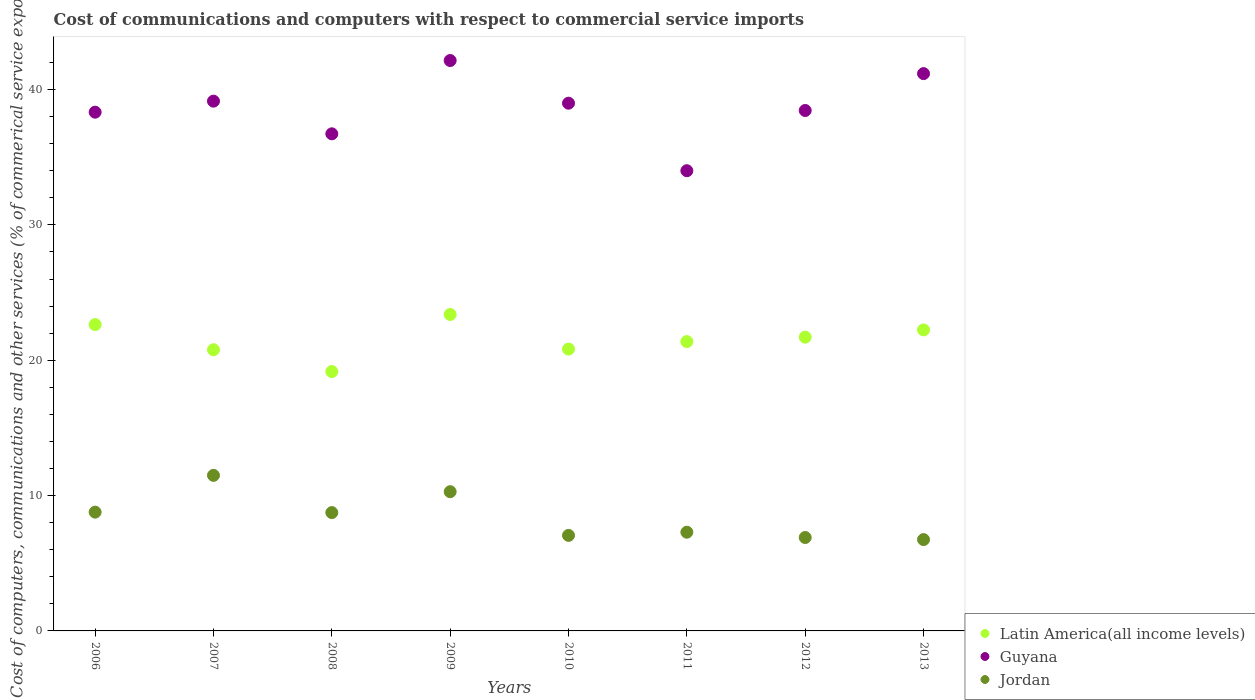What is the cost of communications and computers in Latin America(all income levels) in 2010?
Offer a very short reply. 20.82. Across all years, what is the maximum cost of communications and computers in Latin America(all income levels)?
Provide a succinct answer. 23.38. Across all years, what is the minimum cost of communications and computers in Jordan?
Your response must be concise. 6.75. In which year was the cost of communications and computers in Guyana maximum?
Your answer should be very brief. 2009. In which year was the cost of communications and computers in Latin America(all income levels) minimum?
Provide a succinct answer. 2008. What is the total cost of communications and computers in Guyana in the graph?
Keep it short and to the point. 308.95. What is the difference between the cost of communications and computers in Guyana in 2008 and that in 2013?
Provide a short and direct response. -4.45. What is the difference between the cost of communications and computers in Jordan in 2007 and the cost of communications and computers in Latin America(all income levels) in 2010?
Provide a succinct answer. -9.33. What is the average cost of communications and computers in Jordan per year?
Provide a succinct answer. 8.41. In the year 2012, what is the difference between the cost of communications and computers in Guyana and cost of communications and computers in Latin America(all income levels)?
Keep it short and to the point. 16.75. What is the ratio of the cost of communications and computers in Guyana in 2007 to that in 2008?
Your answer should be compact. 1.07. What is the difference between the highest and the second highest cost of communications and computers in Latin America(all income levels)?
Provide a succinct answer. 0.75. What is the difference between the highest and the lowest cost of communications and computers in Jordan?
Provide a short and direct response. 4.75. In how many years, is the cost of communications and computers in Latin America(all income levels) greater than the average cost of communications and computers in Latin America(all income levels) taken over all years?
Your answer should be very brief. 4. Is the sum of the cost of communications and computers in Latin America(all income levels) in 2006 and 2011 greater than the maximum cost of communications and computers in Guyana across all years?
Offer a very short reply. Yes. Is it the case that in every year, the sum of the cost of communications and computers in Jordan and cost of communications and computers in Latin America(all income levels)  is greater than the cost of communications and computers in Guyana?
Offer a very short reply. No. Is the cost of communications and computers in Jordan strictly greater than the cost of communications and computers in Guyana over the years?
Give a very brief answer. No. Is the cost of communications and computers in Latin America(all income levels) strictly less than the cost of communications and computers in Jordan over the years?
Your response must be concise. No. How many years are there in the graph?
Keep it short and to the point. 8. What is the difference between two consecutive major ticks on the Y-axis?
Make the answer very short. 10. Does the graph contain any zero values?
Offer a terse response. No. Does the graph contain grids?
Make the answer very short. No. What is the title of the graph?
Make the answer very short. Cost of communications and computers with respect to commercial service imports. What is the label or title of the X-axis?
Your answer should be compact. Years. What is the label or title of the Y-axis?
Provide a short and direct response. Cost of computers, communications and other services (% of commerical service exports). What is the Cost of computers, communications and other services (% of commerical service exports) in Latin America(all income levels) in 2006?
Your response must be concise. 22.63. What is the Cost of computers, communications and other services (% of commerical service exports) of Guyana in 2006?
Make the answer very short. 38.33. What is the Cost of computers, communications and other services (% of commerical service exports) of Jordan in 2006?
Ensure brevity in your answer.  8.78. What is the Cost of computers, communications and other services (% of commerical service exports) of Latin America(all income levels) in 2007?
Provide a short and direct response. 20.77. What is the Cost of computers, communications and other services (% of commerical service exports) in Guyana in 2007?
Provide a short and direct response. 39.14. What is the Cost of computers, communications and other services (% of commerical service exports) of Jordan in 2007?
Provide a succinct answer. 11.49. What is the Cost of computers, communications and other services (% of commerical service exports) in Latin America(all income levels) in 2008?
Keep it short and to the point. 19.16. What is the Cost of computers, communications and other services (% of commerical service exports) in Guyana in 2008?
Your answer should be very brief. 36.73. What is the Cost of computers, communications and other services (% of commerical service exports) in Jordan in 2008?
Give a very brief answer. 8.74. What is the Cost of computers, communications and other services (% of commerical service exports) of Latin America(all income levels) in 2009?
Ensure brevity in your answer.  23.38. What is the Cost of computers, communications and other services (% of commerical service exports) in Guyana in 2009?
Offer a very short reply. 42.14. What is the Cost of computers, communications and other services (% of commerical service exports) of Jordan in 2009?
Ensure brevity in your answer.  10.29. What is the Cost of computers, communications and other services (% of commerical service exports) in Latin America(all income levels) in 2010?
Offer a very short reply. 20.82. What is the Cost of computers, communications and other services (% of commerical service exports) in Guyana in 2010?
Your answer should be compact. 38.99. What is the Cost of computers, communications and other services (% of commerical service exports) of Jordan in 2010?
Provide a short and direct response. 7.06. What is the Cost of computers, communications and other services (% of commerical service exports) of Latin America(all income levels) in 2011?
Your response must be concise. 21.38. What is the Cost of computers, communications and other services (% of commerical service exports) in Guyana in 2011?
Your answer should be compact. 34. What is the Cost of computers, communications and other services (% of commerical service exports) of Jordan in 2011?
Your response must be concise. 7.29. What is the Cost of computers, communications and other services (% of commerical service exports) of Latin America(all income levels) in 2012?
Provide a short and direct response. 21.7. What is the Cost of computers, communications and other services (% of commerical service exports) in Guyana in 2012?
Provide a short and direct response. 38.45. What is the Cost of computers, communications and other services (% of commerical service exports) of Jordan in 2012?
Your response must be concise. 6.9. What is the Cost of computers, communications and other services (% of commerical service exports) in Latin America(all income levels) in 2013?
Make the answer very short. 22.24. What is the Cost of computers, communications and other services (% of commerical service exports) in Guyana in 2013?
Offer a terse response. 41.17. What is the Cost of computers, communications and other services (% of commerical service exports) of Jordan in 2013?
Provide a succinct answer. 6.75. Across all years, what is the maximum Cost of computers, communications and other services (% of commerical service exports) of Latin America(all income levels)?
Give a very brief answer. 23.38. Across all years, what is the maximum Cost of computers, communications and other services (% of commerical service exports) in Guyana?
Provide a succinct answer. 42.14. Across all years, what is the maximum Cost of computers, communications and other services (% of commerical service exports) in Jordan?
Keep it short and to the point. 11.49. Across all years, what is the minimum Cost of computers, communications and other services (% of commerical service exports) of Latin America(all income levels)?
Offer a very short reply. 19.16. Across all years, what is the minimum Cost of computers, communications and other services (% of commerical service exports) of Guyana?
Make the answer very short. 34. Across all years, what is the minimum Cost of computers, communications and other services (% of commerical service exports) in Jordan?
Offer a terse response. 6.75. What is the total Cost of computers, communications and other services (% of commerical service exports) in Latin America(all income levels) in the graph?
Offer a terse response. 172.09. What is the total Cost of computers, communications and other services (% of commerical service exports) in Guyana in the graph?
Your answer should be very brief. 308.95. What is the total Cost of computers, communications and other services (% of commerical service exports) in Jordan in the graph?
Your answer should be compact. 67.3. What is the difference between the Cost of computers, communications and other services (% of commerical service exports) in Latin America(all income levels) in 2006 and that in 2007?
Provide a succinct answer. 1.86. What is the difference between the Cost of computers, communications and other services (% of commerical service exports) in Guyana in 2006 and that in 2007?
Your response must be concise. -0.82. What is the difference between the Cost of computers, communications and other services (% of commerical service exports) of Jordan in 2006 and that in 2007?
Offer a very short reply. -2.72. What is the difference between the Cost of computers, communications and other services (% of commerical service exports) in Latin America(all income levels) in 2006 and that in 2008?
Give a very brief answer. 3.47. What is the difference between the Cost of computers, communications and other services (% of commerical service exports) in Guyana in 2006 and that in 2008?
Keep it short and to the point. 1.6. What is the difference between the Cost of computers, communications and other services (% of commerical service exports) of Jordan in 2006 and that in 2008?
Provide a short and direct response. 0.03. What is the difference between the Cost of computers, communications and other services (% of commerical service exports) in Latin America(all income levels) in 2006 and that in 2009?
Offer a terse response. -0.75. What is the difference between the Cost of computers, communications and other services (% of commerical service exports) in Guyana in 2006 and that in 2009?
Provide a succinct answer. -3.82. What is the difference between the Cost of computers, communications and other services (% of commerical service exports) in Jordan in 2006 and that in 2009?
Provide a succinct answer. -1.51. What is the difference between the Cost of computers, communications and other services (% of commerical service exports) in Latin America(all income levels) in 2006 and that in 2010?
Give a very brief answer. 1.81. What is the difference between the Cost of computers, communications and other services (% of commerical service exports) in Guyana in 2006 and that in 2010?
Provide a succinct answer. -0.66. What is the difference between the Cost of computers, communications and other services (% of commerical service exports) of Jordan in 2006 and that in 2010?
Provide a short and direct response. 1.72. What is the difference between the Cost of computers, communications and other services (% of commerical service exports) in Latin America(all income levels) in 2006 and that in 2011?
Ensure brevity in your answer.  1.26. What is the difference between the Cost of computers, communications and other services (% of commerical service exports) in Guyana in 2006 and that in 2011?
Your answer should be very brief. 4.33. What is the difference between the Cost of computers, communications and other services (% of commerical service exports) of Jordan in 2006 and that in 2011?
Provide a short and direct response. 1.48. What is the difference between the Cost of computers, communications and other services (% of commerical service exports) in Guyana in 2006 and that in 2012?
Make the answer very short. -0.13. What is the difference between the Cost of computers, communications and other services (% of commerical service exports) of Jordan in 2006 and that in 2012?
Your response must be concise. 1.88. What is the difference between the Cost of computers, communications and other services (% of commerical service exports) in Latin America(all income levels) in 2006 and that in 2013?
Your answer should be compact. 0.39. What is the difference between the Cost of computers, communications and other services (% of commerical service exports) of Guyana in 2006 and that in 2013?
Give a very brief answer. -2.85. What is the difference between the Cost of computers, communications and other services (% of commerical service exports) of Jordan in 2006 and that in 2013?
Offer a terse response. 2.03. What is the difference between the Cost of computers, communications and other services (% of commerical service exports) in Latin America(all income levels) in 2007 and that in 2008?
Make the answer very short. 1.61. What is the difference between the Cost of computers, communications and other services (% of commerical service exports) in Guyana in 2007 and that in 2008?
Offer a terse response. 2.41. What is the difference between the Cost of computers, communications and other services (% of commerical service exports) of Jordan in 2007 and that in 2008?
Your answer should be compact. 2.75. What is the difference between the Cost of computers, communications and other services (% of commerical service exports) in Latin America(all income levels) in 2007 and that in 2009?
Your answer should be very brief. -2.61. What is the difference between the Cost of computers, communications and other services (% of commerical service exports) in Guyana in 2007 and that in 2009?
Provide a short and direct response. -3. What is the difference between the Cost of computers, communications and other services (% of commerical service exports) of Jordan in 2007 and that in 2009?
Provide a succinct answer. 1.21. What is the difference between the Cost of computers, communications and other services (% of commerical service exports) of Guyana in 2007 and that in 2010?
Provide a succinct answer. 0.15. What is the difference between the Cost of computers, communications and other services (% of commerical service exports) in Jordan in 2007 and that in 2010?
Give a very brief answer. 4.44. What is the difference between the Cost of computers, communications and other services (% of commerical service exports) of Latin America(all income levels) in 2007 and that in 2011?
Make the answer very short. -0.6. What is the difference between the Cost of computers, communications and other services (% of commerical service exports) in Guyana in 2007 and that in 2011?
Your response must be concise. 5.14. What is the difference between the Cost of computers, communications and other services (% of commerical service exports) in Jordan in 2007 and that in 2011?
Make the answer very short. 4.2. What is the difference between the Cost of computers, communications and other services (% of commerical service exports) of Latin America(all income levels) in 2007 and that in 2012?
Your answer should be very brief. -0.93. What is the difference between the Cost of computers, communications and other services (% of commerical service exports) in Guyana in 2007 and that in 2012?
Provide a succinct answer. 0.69. What is the difference between the Cost of computers, communications and other services (% of commerical service exports) in Jordan in 2007 and that in 2012?
Your answer should be compact. 4.59. What is the difference between the Cost of computers, communications and other services (% of commerical service exports) in Latin America(all income levels) in 2007 and that in 2013?
Your response must be concise. -1.47. What is the difference between the Cost of computers, communications and other services (% of commerical service exports) of Guyana in 2007 and that in 2013?
Ensure brevity in your answer.  -2.03. What is the difference between the Cost of computers, communications and other services (% of commerical service exports) of Jordan in 2007 and that in 2013?
Ensure brevity in your answer.  4.75. What is the difference between the Cost of computers, communications and other services (% of commerical service exports) in Latin America(all income levels) in 2008 and that in 2009?
Your answer should be very brief. -4.22. What is the difference between the Cost of computers, communications and other services (% of commerical service exports) in Guyana in 2008 and that in 2009?
Offer a very short reply. -5.42. What is the difference between the Cost of computers, communications and other services (% of commerical service exports) of Jordan in 2008 and that in 2009?
Keep it short and to the point. -1.54. What is the difference between the Cost of computers, communications and other services (% of commerical service exports) in Latin America(all income levels) in 2008 and that in 2010?
Your answer should be very brief. -1.66. What is the difference between the Cost of computers, communications and other services (% of commerical service exports) of Guyana in 2008 and that in 2010?
Make the answer very short. -2.26. What is the difference between the Cost of computers, communications and other services (% of commerical service exports) in Jordan in 2008 and that in 2010?
Offer a terse response. 1.68. What is the difference between the Cost of computers, communications and other services (% of commerical service exports) of Latin America(all income levels) in 2008 and that in 2011?
Offer a terse response. -2.21. What is the difference between the Cost of computers, communications and other services (% of commerical service exports) in Guyana in 2008 and that in 2011?
Your response must be concise. 2.73. What is the difference between the Cost of computers, communications and other services (% of commerical service exports) in Jordan in 2008 and that in 2011?
Your answer should be compact. 1.45. What is the difference between the Cost of computers, communications and other services (% of commerical service exports) of Latin America(all income levels) in 2008 and that in 2012?
Your answer should be very brief. -2.54. What is the difference between the Cost of computers, communications and other services (% of commerical service exports) of Guyana in 2008 and that in 2012?
Ensure brevity in your answer.  -1.72. What is the difference between the Cost of computers, communications and other services (% of commerical service exports) in Jordan in 2008 and that in 2012?
Keep it short and to the point. 1.84. What is the difference between the Cost of computers, communications and other services (% of commerical service exports) in Latin America(all income levels) in 2008 and that in 2013?
Offer a very short reply. -3.08. What is the difference between the Cost of computers, communications and other services (% of commerical service exports) of Guyana in 2008 and that in 2013?
Your response must be concise. -4.45. What is the difference between the Cost of computers, communications and other services (% of commerical service exports) in Jordan in 2008 and that in 2013?
Offer a terse response. 1.99. What is the difference between the Cost of computers, communications and other services (% of commerical service exports) of Latin America(all income levels) in 2009 and that in 2010?
Your answer should be very brief. 2.56. What is the difference between the Cost of computers, communications and other services (% of commerical service exports) of Guyana in 2009 and that in 2010?
Offer a very short reply. 3.15. What is the difference between the Cost of computers, communications and other services (% of commerical service exports) in Jordan in 2009 and that in 2010?
Your answer should be compact. 3.23. What is the difference between the Cost of computers, communications and other services (% of commerical service exports) of Latin America(all income levels) in 2009 and that in 2011?
Your response must be concise. 2. What is the difference between the Cost of computers, communications and other services (% of commerical service exports) in Guyana in 2009 and that in 2011?
Your answer should be very brief. 8.14. What is the difference between the Cost of computers, communications and other services (% of commerical service exports) of Jordan in 2009 and that in 2011?
Provide a succinct answer. 2.99. What is the difference between the Cost of computers, communications and other services (% of commerical service exports) in Latin America(all income levels) in 2009 and that in 2012?
Give a very brief answer. 1.68. What is the difference between the Cost of computers, communications and other services (% of commerical service exports) in Guyana in 2009 and that in 2012?
Your answer should be compact. 3.69. What is the difference between the Cost of computers, communications and other services (% of commerical service exports) of Jordan in 2009 and that in 2012?
Your answer should be very brief. 3.38. What is the difference between the Cost of computers, communications and other services (% of commerical service exports) of Latin America(all income levels) in 2009 and that in 2013?
Your response must be concise. 1.14. What is the difference between the Cost of computers, communications and other services (% of commerical service exports) of Guyana in 2009 and that in 2013?
Ensure brevity in your answer.  0.97. What is the difference between the Cost of computers, communications and other services (% of commerical service exports) of Jordan in 2009 and that in 2013?
Provide a succinct answer. 3.54. What is the difference between the Cost of computers, communications and other services (% of commerical service exports) of Latin America(all income levels) in 2010 and that in 2011?
Offer a very short reply. -0.55. What is the difference between the Cost of computers, communications and other services (% of commerical service exports) of Guyana in 2010 and that in 2011?
Your answer should be very brief. 4.99. What is the difference between the Cost of computers, communications and other services (% of commerical service exports) of Jordan in 2010 and that in 2011?
Provide a succinct answer. -0.23. What is the difference between the Cost of computers, communications and other services (% of commerical service exports) in Latin America(all income levels) in 2010 and that in 2012?
Make the answer very short. -0.88. What is the difference between the Cost of computers, communications and other services (% of commerical service exports) in Guyana in 2010 and that in 2012?
Offer a terse response. 0.54. What is the difference between the Cost of computers, communications and other services (% of commerical service exports) in Jordan in 2010 and that in 2012?
Your response must be concise. 0.16. What is the difference between the Cost of computers, communications and other services (% of commerical service exports) of Latin America(all income levels) in 2010 and that in 2013?
Your answer should be very brief. -1.42. What is the difference between the Cost of computers, communications and other services (% of commerical service exports) in Guyana in 2010 and that in 2013?
Ensure brevity in your answer.  -2.19. What is the difference between the Cost of computers, communications and other services (% of commerical service exports) of Jordan in 2010 and that in 2013?
Give a very brief answer. 0.31. What is the difference between the Cost of computers, communications and other services (% of commerical service exports) in Latin America(all income levels) in 2011 and that in 2012?
Provide a short and direct response. -0.33. What is the difference between the Cost of computers, communications and other services (% of commerical service exports) of Guyana in 2011 and that in 2012?
Offer a very short reply. -4.45. What is the difference between the Cost of computers, communications and other services (% of commerical service exports) in Jordan in 2011 and that in 2012?
Your answer should be compact. 0.39. What is the difference between the Cost of computers, communications and other services (% of commerical service exports) of Latin America(all income levels) in 2011 and that in 2013?
Ensure brevity in your answer.  -0.86. What is the difference between the Cost of computers, communications and other services (% of commerical service exports) in Guyana in 2011 and that in 2013?
Provide a short and direct response. -7.17. What is the difference between the Cost of computers, communications and other services (% of commerical service exports) in Jordan in 2011 and that in 2013?
Your answer should be very brief. 0.55. What is the difference between the Cost of computers, communications and other services (% of commerical service exports) of Latin America(all income levels) in 2012 and that in 2013?
Provide a short and direct response. -0.54. What is the difference between the Cost of computers, communications and other services (% of commerical service exports) of Guyana in 2012 and that in 2013?
Provide a short and direct response. -2.72. What is the difference between the Cost of computers, communications and other services (% of commerical service exports) of Jordan in 2012 and that in 2013?
Make the answer very short. 0.15. What is the difference between the Cost of computers, communications and other services (% of commerical service exports) in Latin America(all income levels) in 2006 and the Cost of computers, communications and other services (% of commerical service exports) in Guyana in 2007?
Give a very brief answer. -16.51. What is the difference between the Cost of computers, communications and other services (% of commerical service exports) of Latin America(all income levels) in 2006 and the Cost of computers, communications and other services (% of commerical service exports) of Jordan in 2007?
Offer a terse response. 11.14. What is the difference between the Cost of computers, communications and other services (% of commerical service exports) of Guyana in 2006 and the Cost of computers, communications and other services (% of commerical service exports) of Jordan in 2007?
Ensure brevity in your answer.  26.83. What is the difference between the Cost of computers, communications and other services (% of commerical service exports) in Latin America(all income levels) in 2006 and the Cost of computers, communications and other services (% of commerical service exports) in Guyana in 2008?
Provide a short and direct response. -14.09. What is the difference between the Cost of computers, communications and other services (% of commerical service exports) of Latin America(all income levels) in 2006 and the Cost of computers, communications and other services (% of commerical service exports) of Jordan in 2008?
Offer a very short reply. 13.89. What is the difference between the Cost of computers, communications and other services (% of commerical service exports) in Guyana in 2006 and the Cost of computers, communications and other services (% of commerical service exports) in Jordan in 2008?
Your answer should be very brief. 29.58. What is the difference between the Cost of computers, communications and other services (% of commerical service exports) of Latin America(all income levels) in 2006 and the Cost of computers, communications and other services (% of commerical service exports) of Guyana in 2009?
Keep it short and to the point. -19.51. What is the difference between the Cost of computers, communications and other services (% of commerical service exports) in Latin America(all income levels) in 2006 and the Cost of computers, communications and other services (% of commerical service exports) in Jordan in 2009?
Provide a short and direct response. 12.35. What is the difference between the Cost of computers, communications and other services (% of commerical service exports) of Guyana in 2006 and the Cost of computers, communications and other services (% of commerical service exports) of Jordan in 2009?
Offer a very short reply. 28.04. What is the difference between the Cost of computers, communications and other services (% of commerical service exports) in Latin America(all income levels) in 2006 and the Cost of computers, communications and other services (% of commerical service exports) in Guyana in 2010?
Provide a short and direct response. -16.36. What is the difference between the Cost of computers, communications and other services (% of commerical service exports) of Latin America(all income levels) in 2006 and the Cost of computers, communications and other services (% of commerical service exports) of Jordan in 2010?
Provide a short and direct response. 15.57. What is the difference between the Cost of computers, communications and other services (% of commerical service exports) of Guyana in 2006 and the Cost of computers, communications and other services (% of commerical service exports) of Jordan in 2010?
Offer a terse response. 31.27. What is the difference between the Cost of computers, communications and other services (% of commerical service exports) in Latin America(all income levels) in 2006 and the Cost of computers, communications and other services (% of commerical service exports) in Guyana in 2011?
Provide a short and direct response. -11.37. What is the difference between the Cost of computers, communications and other services (% of commerical service exports) of Latin America(all income levels) in 2006 and the Cost of computers, communications and other services (% of commerical service exports) of Jordan in 2011?
Your response must be concise. 15.34. What is the difference between the Cost of computers, communications and other services (% of commerical service exports) of Guyana in 2006 and the Cost of computers, communications and other services (% of commerical service exports) of Jordan in 2011?
Give a very brief answer. 31.03. What is the difference between the Cost of computers, communications and other services (% of commerical service exports) in Latin America(all income levels) in 2006 and the Cost of computers, communications and other services (% of commerical service exports) in Guyana in 2012?
Offer a terse response. -15.82. What is the difference between the Cost of computers, communications and other services (% of commerical service exports) of Latin America(all income levels) in 2006 and the Cost of computers, communications and other services (% of commerical service exports) of Jordan in 2012?
Offer a very short reply. 15.73. What is the difference between the Cost of computers, communications and other services (% of commerical service exports) of Guyana in 2006 and the Cost of computers, communications and other services (% of commerical service exports) of Jordan in 2012?
Provide a succinct answer. 31.42. What is the difference between the Cost of computers, communications and other services (% of commerical service exports) of Latin America(all income levels) in 2006 and the Cost of computers, communications and other services (% of commerical service exports) of Guyana in 2013?
Ensure brevity in your answer.  -18.54. What is the difference between the Cost of computers, communications and other services (% of commerical service exports) of Latin America(all income levels) in 2006 and the Cost of computers, communications and other services (% of commerical service exports) of Jordan in 2013?
Make the answer very short. 15.88. What is the difference between the Cost of computers, communications and other services (% of commerical service exports) in Guyana in 2006 and the Cost of computers, communications and other services (% of commerical service exports) in Jordan in 2013?
Provide a short and direct response. 31.58. What is the difference between the Cost of computers, communications and other services (% of commerical service exports) in Latin America(all income levels) in 2007 and the Cost of computers, communications and other services (% of commerical service exports) in Guyana in 2008?
Offer a terse response. -15.95. What is the difference between the Cost of computers, communications and other services (% of commerical service exports) of Latin America(all income levels) in 2007 and the Cost of computers, communications and other services (% of commerical service exports) of Jordan in 2008?
Keep it short and to the point. 12.03. What is the difference between the Cost of computers, communications and other services (% of commerical service exports) of Guyana in 2007 and the Cost of computers, communications and other services (% of commerical service exports) of Jordan in 2008?
Your response must be concise. 30.4. What is the difference between the Cost of computers, communications and other services (% of commerical service exports) of Latin America(all income levels) in 2007 and the Cost of computers, communications and other services (% of commerical service exports) of Guyana in 2009?
Your response must be concise. -21.37. What is the difference between the Cost of computers, communications and other services (% of commerical service exports) in Latin America(all income levels) in 2007 and the Cost of computers, communications and other services (% of commerical service exports) in Jordan in 2009?
Your answer should be very brief. 10.49. What is the difference between the Cost of computers, communications and other services (% of commerical service exports) of Guyana in 2007 and the Cost of computers, communications and other services (% of commerical service exports) of Jordan in 2009?
Your response must be concise. 28.85. What is the difference between the Cost of computers, communications and other services (% of commerical service exports) of Latin America(all income levels) in 2007 and the Cost of computers, communications and other services (% of commerical service exports) of Guyana in 2010?
Offer a terse response. -18.22. What is the difference between the Cost of computers, communications and other services (% of commerical service exports) of Latin America(all income levels) in 2007 and the Cost of computers, communications and other services (% of commerical service exports) of Jordan in 2010?
Offer a terse response. 13.72. What is the difference between the Cost of computers, communications and other services (% of commerical service exports) in Guyana in 2007 and the Cost of computers, communications and other services (% of commerical service exports) in Jordan in 2010?
Provide a succinct answer. 32.08. What is the difference between the Cost of computers, communications and other services (% of commerical service exports) in Latin America(all income levels) in 2007 and the Cost of computers, communications and other services (% of commerical service exports) in Guyana in 2011?
Keep it short and to the point. -13.23. What is the difference between the Cost of computers, communications and other services (% of commerical service exports) in Latin America(all income levels) in 2007 and the Cost of computers, communications and other services (% of commerical service exports) in Jordan in 2011?
Your response must be concise. 13.48. What is the difference between the Cost of computers, communications and other services (% of commerical service exports) of Guyana in 2007 and the Cost of computers, communications and other services (% of commerical service exports) of Jordan in 2011?
Your response must be concise. 31.85. What is the difference between the Cost of computers, communications and other services (% of commerical service exports) in Latin America(all income levels) in 2007 and the Cost of computers, communications and other services (% of commerical service exports) in Guyana in 2012?
Provide a short and direct response. -17.68. What is the difference between the Cost of computers, communications and other services (% of commerical service exports) of Latin America(all income levels) in 2007 and the Cost of computers, communications and other services (% of commerical service exports) of Jordan in 2012?
Offer a very short reply. 13.87. What is the difference between the Cost of computers, communications and other services (% of commerical service exports) of Guyana in 2007 and the Cost of computers, communications and other services (% of commerical service exports) of Jordan in 2012?
Ensure brevity in your answer.  32.24. What is the difference between the Cost of computers, communications and other services (% of commerical service exports) of Latin America(all income levels) in 2007 and the Cost of computers, communications and other services (% of commerical service exports) of Guyana in 2013?
Give a very brief answer. -20.4. What is the difference between the Cost of computers, communications and other services (% of commerical service exports) in Latin America(all income levels) in 2007 and the Cost of computers, communications and other services (% of commerical service exports) in Jordan in 2013?
Provide a succinct answer. 14.03. What is the difference between the Cost of computers, communications and other services (% of commerical service exports) of Guyana in 2007 and the Cost of computers, communications and other services (% of commerical service exports) of Jordan in 2013?
Keep it short and to the point. 32.39. What is the difference between the Cost of computers, communications and other services (% of commerical service exports) in Latin America(all income levels) in 2008 and the Cost of computers, communications and other services (% of commerical service exports) in Guyana in 2009?
Ensure brevity in your answer.  -22.98. What is the difference between the Cost of computers, communications and other services (% of commerical service exports) of Latin America(all income levels) in 2008 and the Cost of computers, communications and other services (% of commerical service exports) of Jordan in 2009?
Offer a very short reply. 8.88. What is the difference between the Cost of computers, communications and other services (% of commerical service exports) in Guyana in 2008 and the Cost of computers, communications and other services (% of commerical service exports) in Jordan in 2009?
Offer a terse response. 26.44. What is the difference between the Cost of computers, communications and other services (% of commerical service exports) in Latin America(all income levels) in 2008 and the Cost of computers, communications and other services (% of commerical service exports) in Guyana in 2010?
Keep it short and to the point. -19.83. What is the difference between the Cost of computers, communications and other services (% of commerical service exports) of Latin America(all income levels) in 2008 and the Cost of computers, communications and other services (% of commerical service exports) of Jordan in 2010?
Offer a very short reply. 12.1. What is the difference between the Cost of computers, communications and other services (% of commerical service exports) in Guyana in 2008 and the Cost of computers, communications and other services (% of commerical service exports) in Jordan in 2010?
Your answer should be very brief. 29.67. What is the difference between the Cost of computers, communications and other services (% of commerical service exports) of Latin America(all income levels) in 2008 and the Cost of computers, communications and other services (% of commerical service exports) of Guyana in 2011?
Your response must be concise. -14.84. What is the difference between the Cost of computers, communications and other services (% of commerical service exports) of Latin America(all income levels) in 2008 and the Cost of computers, communications and other services (% of commerical service exports) of Jordan in 2011?
Ensure brevity in your answer.  11.87. What is the difference between the Cost of computers, communications and other services (% of commerical service exports) of Guyana in 2008 and the Cost of computers, communications and other services (% of commerical service exports) of Jordan in 2011?
Provide a short and direct response. 29.43. What is the difference between the Cost of computers, communications and other services (% of commerical service exports) in Latin America(all income levels) in 2008 and the Cost of computers, communications and other services (% of commerical service exports) in Guyana in 2012?
Your answer should be very brief. -19.29. What is the difference between the Cost of computers, communications and other services (% of commerical service exports) in Latin America(all income levels) in 2008 and the Cost of computers, communications and other services (% of commerical service exports) in Jordan in 2012?
Give a very brief answer. 12.26. What is the difference between the Cost of computers, communications and other services (% of commerical service exports) in Guyana in 2008 and the Cost of computers, communications and other services (% of commerical service exports) in Jordan in 2012?
Your answer should be compact. 29.82. What is the difference between the Cost of computers, communications and other services (% of commerical service exports) in Latin America(all income levels) in 2008 and the Cost of computers, communications and other services (% of commerical service exports) in Guyana in 2013?
Your answer should be compact. -22.01. What is the difference between the Cost of computers, communications and other services (% of commerical service exports) in Latin America(all income levels) in 2008 and the Cost of computers, communications and other services (% of commerical service exports) in Jordan in 2013?
Your answer should be very brief. 12.41. What is the difference between the Cost of computers, communications and other services (% of commerical service exports) in Guyana in 2008 and the Cost of computers, communications and other services (% of commerical service exports) in Jordan in 2013?
Your answer should be very brief. 29.98. What is the difference between the Cost of computers, communications and other services (% of commerical service exports) of Latin America(all income levels) in 2009 and the Cost of computers, communications and other services (% of commerical service exports) of Guyana in 2010?
Give a very brief answer. -15.61. What is the difference between the Cost of computers, communications and other services (% of commerical service exports) in Latin America(all income levels) in 2009 and the Cost of computers, communications and other services (% of commerical service exports) in Jordan in 2010?
Ensure brevity in your answer.  16.32. What is the difference between the Cost of computers, communications and other services (% of commerical service exports) of Guyana in 2009 and the Cost of computers, communications and other services (% of commerical service exports) of Jordan in 2010?
Provide a short and direct response. 35.08. What is the difference between the Cost of computers, communications and other services (% of commerical service exports) of Latin America(all income levels) in 2009 and the Cost of computers, communications and other services (% of commerical service exports) of Guyana in 2011?
Make the answer very short. -10.62. What is the difference between the Cost of computers, communications and other services (% of commerical service exports) in Latin America(all income levels) in 2009 and the Cost of computers, communications and other services (% of commerical service exports) in Jordan in 2011?
Offer a very short reply. 16.09. What is the difference between the Cost of computers, communications and other services (% of commerical service exports) of Guyana in 2009 and the Cost of computers, communications and other services (% of commerical service exports) of Jordan in 2011?
Your answer should be very brief. 34.85. What is the difference between the Cost of computers, communications and other services (% of commerical service exports) of Latin America(all income levels) in 2009 and the Cost of computers, communications and other services (% of commerical service exports) of Guyana in 2012?
Provide a short and direct response. -15.07. What is the difference between the Cost of computers, communications and other services (% of commerical service exports) in Latin America(all income levels) in 2009 and the Cost of computers, communications and other services (% of commerical service exports) in Jordan in 2012?
Give a very brief answer. 16.48. What is the difference between the Cost of computers, communications and other services (% of commerical service exports) in Guyana in 2009 and the Cost of computers, communications and other services (% of commerical service exports) in Jordan in 2012?
Provide a succinct answer. 35.24. What is the difference between the Cost of computers, communications and other services (% of commerical service exports) of Latin America(all income levels) in 2009 and the Cost of computers, communications and other services (% of commerical service exports) of Guyana in 2013?
Offer a terse response. -17.79. What is the difference between the Cost of computers, communications and other services (% of commerical service exports) in Latin America(all income levels) in 2009 and the Cost of computers, communications and other services (% of commerical service exports) in Jordan in 2013?
Provide a short and direct response. 16.63. What is the difference between the Cost of computers, communications and other services (% of commerical service exports) in Guyana in 2009 and the Cost of computers, communications and other services (% of commerical service exports) in Jordan in 2013?
Your response must be concise. 35.39. What is the difference between the Cost of computers, communications and other services (% of commerical service exports) in Latin America(all income levels) in 2010 and the Cost of computers, communications and other services (% of commerical service exports) in Guyana in 2011?
Provide a succinct answer. -13.18. What is the difference between the Cost of computers, communications and other services (% of commerical service exports) in Latin America(all income levels) in 2010 and the Cost of computers, communications and other services (% of commerical service exports) in Jordan in 2011?
Keep it short and to the point. 13.53. What is the difference between the Cost of computers, communications and other services (% of commerical service exports) of Guyana in 2010 and the Cost of computers, communications and other services (% of commerical service exports) of Jordan in 2011?
Ensure brevity in your answer.  31.7. What is the difference between the Cost of computers, communications and other services (% of commerical service exports) in Latin America(all income levels) in 2010 and the Cost of computers, communications and other services (% of commerical service exports) in Guyana in 2012?
Give a very brief answer. -17.63. What is the difference between the Cost of computers, communications and other services (% of commerical service exports) in Latin America(all income levels) in 2010 and the Cost of computers, communications and other services (% of commerical service exports) in Jordan in 2012?
Ensure brevity in your answer.  13.92. What is the difference between the Cost of computers, communications and other services (% of commerical service exports) in Guyana in 2010 and the Cost of computers, communications and other services (% of commerical service exports) in Jordan in 2012?
Keep it short and to the point. 32.09. What is the difference between the Cost of computers, communications and other services (% of commerical service exports) of Latin America(all income levels) in 2010 and the Cost of computers, communications and other services (% of commerical service exports) of Guyana in 2013?
Offer a very short reply. -20.35. What is the difference between the Cost of computers, communications and other services (% of commerical service exports) in Latin America(all income levels) in 2010 and the Cost of computers, communications and other services (% of commerical service exports) in Jordan in 2013?
Your response must be concise. 14.08. What is the difference between the Cost of computers, communications and other services (% of commerical service exports) in Guyana in 2010 and the Cost of computers, communications and other services (% of commerical service exports) in Jordan in 2013?
Offer a very short reply. 32.24. What is the difference between the Cost of computers, communications and other services (% of commerical service exports) of Latin America(all income levels) in 2011 and the Cost of computers, communications and other services (% of commerical service exports) of Guyana in 2012?
Provide a succinct answer. -17.07. What is the difference between the Cost of computers, communications and other services (% of commerical service exports) of Latin America(all income levels) in 2011 and the Cost of computers, communications and other services (% of commerical service exports) of Jordan in 2012?
Your answer should be compact. 14.47. What is the difference between the Cost of computers, communications and other services (% of commerical service exports) in Guyana in 2011 and the Cost of computers, communications and other services (% of commerical service exports) in Jordan in 2012?
Offer a terse response. 27.1. What is the difference between the Cost of computers, communications and other services (% of commerical service exports) in Latin America(all income levels) in 2011 and the Cost of computers, communications and other services (% of commerical service exports) in Guyana in 2013?
Offer a terse response. -19.8. What is the difference between the Cost of computers, communications and other services (% of commerical service exports) in Latin America(all income levels) in 2011 and the Cost of computers, communications and other services (% of commerical service exports) in Jordan in 2013?
Give a very brief answer. 14.63. What is the difference between the Cost of computers, communications and other services (% of commerical service exports) of Guyana in 2011 and the Cost of computers, communications and other services (% of commerical service exports) of Jordan in 2013?
Make the answer very short. 27.25. What is the difference between the Cost of computers, communications and other services (% of commerical service exports) in Latin America(all income levels) in 2012 and the Cost of computers, communications and other services (% of commerical service exports) in Guyana in 2013?
Ensure brevity in your answer.  -19.47. What is the difference between the Cost of computers, communications and other services (% of commerical service exports) in Latin America(all income levels) in 2012 and the Cost of computers, communications and other services (% of commerical service exports) in Jordan in 2013?
Your answer should be very brief. 14.96. What is the difference between the Cost of computers, communications and other services (% of commerical service exports) of Guyana in 2012 and the Cost of computers, communications and other services (% of commerical service exports) of Jordan in 2013?
Ensure brevity in your answer.  31.7. What is the average Cost of computers, communications and other services (% of commerical service exports) of Latin America(all income levels) per year?
Ensure brevity in your answer.  21.51. What is the average Cost of computers, communications and other services (% of commerical service exports) of Guyana per year?
Your answer should be very brief. 38.62. What is the average Cost of computers, communications and other services (% of commerical service exports) of Jordan per year?
Provide a succinct answer. 8.41. In the year 2006, what is the difference between the Cost of computers, communications and other services (% of commerical service exports) in Latin America(all income levels) and Cost of computers, communications and other services (% of commerical service exports) in Guyana?
Provide a short and direct response. -15.69. In the year 2006, what is the difference between the Cost of computers, communications and other services (% of commerical service exports) in Latin America(all income levels) and Cost of computers, communications and other services (% of commerical service exports) in Jordan?
Give a very brief answer. 13.86. In the year 2006, what is the difference between the Cost of computers, communications and other services (% of commerical service exports) of Guyana and Cost of computers, communications and other services (% of commerical service exports) of Jordan?
Give a very brief answer. 29.55. In the year 2007, what is the difference between the Cost of computers, communications and other services (% of commerical service exports) in Latin America(all income levels) and Cost of computers, communications and other services (% of commerical service exports) in Guyana?
Offer a terse response. -18.37. In the year 2007, what is the difference between the Cost of computers, communications and other services (% of commerical service exports) of Latin America(all income levels) and Cost of computers, communications and other services (% of commerical service exports) of Jordan?
Provide a succinct answer. 9.28. In the year 2007, what is the difference between the Cost of computers, communications and other services (% of commerical service exports) of Guyana and Cost of computers, communications and other services (% of commerical service exports) of Jordan?
Keep it short and to the point. 27.65. In the year 2008, what is the difference between the Cost of computers, communications and other services (% of commerical service exports) of Latin America(all income levels) and Cost of computers, communications and other services (% of commerical service exports) of Guyana?
Your response must be concise. -17.56. In the year 2008, what is the difference between the Cost of computers, communications and other services (% of commerical service exports) of Latin America(all income levels) and Cost of computers, communications and other services (% of commerical service exports) of Jordan?
Offer a very short reply. 10.42. In the year 2008, what is the difference between the Cost of computers, communications and other services (% of commerical service exports) of Guyana and Cost of computers, communications and other services (% of commerical service exports) of Jordan?
Make the answer very short. 27.98. In the year 2009, what is the difference between the Cost of computers, communications and other services (% of commerical service exports) of Latin America(all income levels) and Cost of computers, communications and other services (% of commerical service exports) of Guyana?
Provide a short and direct response. -18.76. In the year 2009, what is the difference between the Cost of computers, communications and other services (% of commerical service exports) in Latin America(all income levels) and Cost of computers, communications and other services (% of commerical service exports) in Jordan?
Your response must be concise. 13.09. In the year 2009, what is the difference between the Cost of computers, communications and other services (% of commerical service exports) in Guyana and Cost of computers, communications and other services (% of commerical service exports) in Jordan?
Give a very brief answer. 31.86. In the year 2010, what is the difference between the Cost of computers, communications and other services (% of commerical service exports) in Latin America(all income levels) and Cost of computers, communications and other services (% of commerical service exports) in Guyana?
Offer a very short reply. -18.17. In the year 2010, what is the difference between the Cost of computers, communications and other services (% of commerical service exports) of Latin America(all income levels) and Cost of computers, communications and other services (% of commerical service exports) of Jordan?
Offer a terse response. 13.77. In the year 2010, what is the difference between the Cost of computers, communications and other services (% of commerical service exports) in Guyana and Cost of computers, communications and other services (% of commerical service exports) in Jordan?
Your answer should be compact. 31.93. In the year 2011, what is the difference between the Cost of computers, communications and other services (% of commerical service exports) of Latin America(all income levels) and Cost of computers, communications and other services (% of commerical service exports) of Guyana?
Ensure brevity in your answer.  -12.62. In the year 2011, what is the difference between the Cost of computers, communications and other services (% of commerical service exports) of Latin America(all income levels) and Cost of computers, communications and other services (% of commerical service exports) of Jordan?
Offer a very short reply. 14.08. In the year 2011, what is the difference between the Cost of computers, communications and other services (% of commerical service exports) of Guyana and Cost of computers, communications and other services (% of commerical service exports) of Jordan?
Give a very brief answer. 26.71. In the year 2012, what is the difference between the Cost of computers, communications and other services (% of commerical service exports) in Latin America(all income levels) and Cost of computers, communications and other services (% of commerical service exports) in Guyana?
Offer a terse response. -16.75. In the year 2012, what is the difference between the Cost of computers, communications and other services (% of commerical service exports) in Latin America(all income levels) and Cost of computers, communications and other services (% of commerical service exports) in Jordan?
Ensure brevity in your answer.  14.8. In the year 2012, what is the difference between the Cost of computers, communications and other services (% of commerical service exports) of Guyana and Cost of computers, communications and other services (% of commerical service exports) of Jordan?
Make the answer very short. 31.55. In the year 2013, what is the difference between the Cost of computers, communications and other services (% of commerical service exports) in Latin America(all income levels) and Cost of computers, communications and other services (% of commerical service exports) in Guyana?
Make the answer very short. -18.94. In the year 2013, what is the difference between the Cost of computers, communications and other services (% of commerical service exports) in Latin America(all income levels) and Cost of computers, communications and other services (% of commerical service exports) in Jordan?
Provide a short and direct response. 15.49. In the year 2013, what is the difference between the Cost of computers, communications and other services (% of commerical service exports) of Guyana and Cost of computers, communications and other services (% of commerical service exports) of Jordan?
Your response must be concise. 34.43. What is the ratio of the Cost of computers, communications and other services (% of commerical service exports) of Latin America(all income levels) in 2006 to that in 2007?
Give a very brief answer. 1.09. What is the ratio of the Cost of computers, communications and other services (% of commerical service exports) in Guyana in 2006 to that in 2007?
Offer a terse response. 0.98. What is the ratio of the Cost of computers, communications and other services (% of commerical service exports) of Jordan in 2006 to that in 2007?
Your response must be concise. 0.76. What is the ratio of the Cost of computers, communications and other services (% of commerical service exports) of Latin America(all income levels) in 2006 to that in 2008?
Offer a terse response. 1.18. What is the ratio of the Cost of computers, communications and other services (% of commerical service exports) of Guyana in 2006 to that in 2008?
Offer a terse response. 1.04. What is the ratio of the Cost of computers, communications and other services (% of commerical service exports) in Guyana in 2006 to that in 2009?
Offer a very short reply. 0.91. What is the ratio of the Cost of computers, communications and other services (% of commerical service exports) of Jordan in 2006 to that in 2009?
Keep it short and to the point. 0.85. What is the ratio of the Cost of computers, communications and other services (% of commerical service exports) in Latin America(all income levels) in 2006 to that in 2010?
Offer a very short reply. 1.09. What is the ratio of the Cost of computers, communications and other services (% of commerical service exports) in Jordan in 2006 to that in 2010?
Ensure brevity in your answer.  1.24. What is the ratio of the Cost of computers, communications and other services (% of commerical service exports) of Latin America(all income levels) in 2006 to that in 2011?
Offer a very short reply. 1.06. What is the ratio of the Cost of computers, communications and other services (% of commerical service exports) in Guyana in 2006 to that in 2011?
Ensure brevity in your answer.  1.13. What is the ratio of the Cost of computers, communications and other services (% of commerical service exports) in Jordan in 2006 to that in 2011?
Offer a very short reply. 1.2. What is the ratio of the Cost of computers, communications and other services (% of commerical service exports) in Latin America(all income levels) in 2006 to that in 2012?
Your response must be concise. 1.04. What is the ratio of the Cost of computers, communications and other services (% of commerical service exports) in Guyana in 2006 to that in 2012?
Ensure brevity in your answer.  1. What is the ratio of the Cost of computers, communications and other services (% of commerical service exports) in Jordan in 2006 to that in 2012?
Your answer should be compact. 1.27. What is the ratio of the Cost of computers, communications and other services (% of commerical service exports) of Latin America(all income levels) in 2006 to that in 2013?
Your answer should be compact. 1.02. What is the ratio of the Cost of computers, communications and other services (% of commerical service exports) in Guyana in 2006 to that in 2013?
Keep it short and to the point. 0.93. What is the ratio of the Cost of computers, communications and other services (% of commerical service exports) of Jordan in 2006 to that in 2013?
Your answer should be compact. 1.3. What is the ratio of the Cost of computers, communications and other services (% of commerical service exports) of Latin America(all income levels) in 2007 to that in 2008?
Give a very brief answer. 1.08. What is the ratio of the Cost of computers, communications and other services (% of commerical service exports) in Guyana in 2007 to that in 2008?
Your answer should be compact. 1.07. What is the ratio of the Cost of computers, communications and other services (% of commerical service exports) of Jordan in 2007 to that in 2008?
Your answer should be compact. 1.31. What is the ratio of the Cost of computers, communications and other services (% of commerical service exports) of Latin America(all income levels) in 2007 to that in 2009?
Your answer should be very brief. 0.89. What is the ratio of the Cost of computers, communications and other services (% of commerical service exports) of Guyana in 2007 to that in 2009?
Your response must be concise. 0.93. What is the ratio of the Cost of computers, communications and other services (% of commerical service exports) of Jordan in 2007 to that in 2009?
Offer a terse response. 1.12. What is the ratio of the Cost of computers, communications and other services (% of commerical service exports) of Guyana in 2007 to that in 2010?
Keep it short and to the point. 1. What is the ratio of the Cost of computers, communications and other services (% of commerical service exports) of Jordan in 2007 to that in 2010?
Make the answer very short. 1.63. What is the ratio of the Cost of computers, communications and other services (% of commerical service exports) in Latin America(all income levels) in 2007 to that in 2011?
Your answer should be compact. 0.97. What is the ratio of the Cost of computers, communications and other services (% of commerical service exports) of Guyana in 2007 to that in 2011?
Offer a terse response. 1.15. What is the ratio of the Cost of computers, communications and other services (% of commerical service exports) of Jordan in 2007 to that in 2011?
Your response must be concise. 1.58. What is the ratio of the Cost of computers, communications and other services (% of commerical service exports) in Latin America(all income levels) in 2007 to that in 2012?
Your response must be concise. 0.96. What is the ratio of the Cost of computers, communications and other services (% of commerical service exports) of Jordan in 2007 to that in 2012?
Offer a very short reply. 1.67. What is the ratio of the Cost of computers, communications and other services (% of commerical service exports) in Latin America(all income levels) in 2007 to that in 2013?
Your answer should be very brief. 0.93. What is the ratio of the Cost of computers, communications and other services (% of commerical service exports) in Guyana in 2007 to that in 2013?
Offer a terse response. 0.95. What is the ratio of the Cost of computers, communications and other services (% of commerical service exports) in Jordan in 2007 to that in 2013?
Your response must be concise. 1.7. What is the ratio of the Cost of computers, communications and other services (% of commerical service exports) of Latin America(all income levels) in 2008 to that in 2009?
Offer a terse response. 0.82. What is the ratio of the Cost of computers, communications and other services (% of commerical service exports) in Guyana in 2008 to that in 2009?
Your response must be concise. 0.87. What is the ratio of the Cost of computers, communications and other services (% of commerical service exports) in Jordan in 2008 to that in 2009?
Your answer should be very brief. 0.85. What is the ratio of the Cost of computers, communications and other services (% of commerical service exports) in Latin America(all income levels) in 2008 to that in 2010?
Give a very brief answer. 0.92. What is the ratio of the Cost of computers, communications and other services (% of commerical service exports) in Guyana in 2008 to that in 2010?
Your answer should be very brief. 0.94. What is the ratio of the Cost of computers, communications and other services (% of commerical service exports) of Jordan in 2008 to that in 2010?
Offer a terse response. 1.24. What is the ratio of the Cost of computers, communications and other services (% of commerical service exports) of Latin America(all income levels) in 2008 to that in 2011?
Offer a terse response. 0.9. What is the ratio of the Cost of computers, communications and other services (% of commerical service exports) in Guyana in 2008 to that in 2011?
Offer a terse response. 1.08. What is the ratio of the Cost of computers, communications and other services (% of commerical service exports) of Jordan in 2008 to that in 2011?
Ensure brevity in your answer.  1.2. What is the ratio of the Cost of computers, communications and other services (% of commerical service exports) in Latin America(all income levels) in 2008 to that in 2012?
Your answer should be compact. 0.88. What is the ratio of the Cost of computers, communications and other services (% of commerical service exports) of Guyana in 2008 to that in 2012?
Offer a very short reply. 0.96. What is the ratio of the Cost of computers, communications and other services (% of commerical service exports) of Jordan in 2008 to that in 2012?
Your answer should be very brief. 1.27. What is the ratio of the Cost of computers, communications and other services (% of commerical service exports) of Latin America(all income levels) in 2008 to that in 2013?
Your response must be concise. 0.86. What is the ratio of the Cost of computers, communications and other services (% of commerical service exports) in Guyana in 2008 to that in 2013?
Offer a terse response. 0.89. What is the ratio of the Cost of computers, communications and other services (% of commerical service exports) in Jordan in 2008 to that in 2013?
Your response must be concise. 1.3. What is the ratio of the Cost of computers, communications and other services (% of commerical service exports) of Latin America(all income levels) in 2009 to that in 2010?
Provide a succinct answer. 1.12. What is the ratio of the Cost of computers, communications and other services (% of commerical service exports) in Guyana in 2009 to that in 2010?
Ensure brevity in your answer.  1.08. What is the ratio of the Cost of computers, communications and other services (% of commerical service exports) of Jordan in 2009 to that in 2010?
Offer a terse response. 1.46. What is the ratio of the Cost of computers, communications and other services (% of commerical service exports) of Latin America(all income levels) in 2009 to that in 2011?
Offer a very short reply. 1.09. What is the ratio of the Cost of computers, communications and other services (% of commerical service exports) in Guyana in 2009 to that in 2011?
Your response must be concise. 1.24. What is the ratio of the Cost of computers, communications and other services (% of commerical service exports) of Jordan in 2009 to that in 2011?
Make the answer very short. 1.41. What is the ratio of the Cost of computers, communications and other services (% of commerical service exports) of Latin America(all income levels) in 2009 to that in 2012?
Your answer should be very brief. 1.08. What is the ratio of the Cost of computers, communications and other services (% of commerical service exports) in Guyana in 2009 to that in 2012?
Make the answer very short. 1.1. What is the ratio of the Cost of computers, communications and other services (% of commerical service exports) in Jordan in 2009 to that in 2012?
Make the answer very short. 1.49. What is the ratio of the Cost of computers, communications and other services (% of commerical service exports) of Latin America(all income levels) in 2009 to that in 2013?
Your answer should be very brief. 1.05. What is the ratio of the Cost of computers, communications and other services (% of commerical service exports) of Guyana in 2009 to that in 2013?
Offer a very short reply. 1.02. What is the ratio of the Cost of computers, communications and other services (% of commerical service exports) of Jordan in 2009 to that in 2013?
Your response must be concise. 1.52. What is the ratio of the Cost of computers, communications and other services (% of commerical service exports) in Latin America(all income levels) in 2010 to that in 2011?
Give a very brief answer. 0.97. What is the ratio of the Cost of computers, communications and other services (% of commerical service exports) in Guyana in 2010 to that in 2011?
Your answer should be compact. 1.15. What is the ratio of the Cost of computers, communications and other services (% of commerical service exports) of Jordan in 2010 to that in 2011?
Your answer should be very brief. 0.97. What is the ratio of the Cost of computers, communications and other services (% of commerical service exports) in Latin America(all income levels) in 2010 to that in 2012?
Provide a short and direct response. 0.96. What is the ratio of the Cost of computers, communications and other services (% of commerical service exports) of Guyana in 2010 to that in 2012?
Your answer should be compact. 1.01. What is the ratio of the Cost of computers, communications and other services (% of commerical service exports) in Jordan in 2010 to that in 2012?
Keep it short and to the point. 1.02. What is the ratio of the Cost of computers, communications and other services (% of commerical service exports) in Latin America(all income levels) in 2010 to that in 2013?
Offer a very short reply. 0.94. What is the ratio of the Cost of computers, communications and other services (% of commerical service exports) of Guyana in 2010 to that in 2013?
Offer a very short reply. 0.95. What is the ratio of the Cost of computers, communications and other services (% of commerical service exports) in Jordan in 2010 to that in 2013?
Ensure brevity in your answer.  1.05. What is the ratio of the Cost of computers, communications and other services (% of commerical service exports) of Latin America(all income levels) in 2011 to that in 2012?
Provide a short and direct response. 0.98. What is the ratio of the Cost of computers, communications and other services (% of commerical service exports) in Guyana in 2011 to that in 2012?
Ensure brevity in your answer.  0.88. What is the ratio of the Cost of computers, communications and other services (% of commerical service exports) of Jordan in 2011 to that in 2012?
Your answer should be compact. 1.06. What is the ratio of the Cost of computers, communications and other services (% of commerical service exports) of Latin America(all income levels) in 2011 to that in 2013?
Your answer should be compact. 0.96. What is the ratio of the Cost of computers, communications and other services (% of commerical service exports) of Guyana in 2011 to that in 2013?
Offer a terse response. 0.83. What is the ratio of the Cost of computers, communications and other services (% of commerical service exports) in Jordan in 2011 to that in 2013?
Make the answer very short. 1.08. What is the ratio of the Cost of computers, communications and other services (% of commerical service exports) in Latin America(all income levels) in 2012 to that in 2013?
Your answer should be compact. 0.98. What is the ratio of the Cost of computers, communications and other services (% of commerical service exports) in Guyana in 2012 to that in 2013?
Offer a very short reply. 0.93. What is the ratio of the Cost of computers, communications and other services (% of commerical service exports) of Jordan in 2012 to that in 2013?
Your answer should be compact. 1.02. What is the difference between the highest and the second highest Cost of computers, communications and other services (% of commerical service exports) of Latin America(all income levels)?
Keep it short and to the point. 0.75. What is the difference between the highest and the second highest Cost of computers, communications and other services (% of commerical service exports) in Guyana?
Make the answer very short. 0.97. What is the difference between the highest and the second highest Cost of computers, communications and other services (% of commerical service exports) of Jordan?
Offer a terse response. 1.21. What is the difference between the highest and the lowest Cost of computers, communications and other services (% of commerical service exports) of Latin America(all income levels)?
Keep it short and to the point. 4.22. What is the difference between the highest and the lowest Cost of computers, communications and other services (% of commerical service exports) of Guyana?
Offer a terse response. 8.14. What is the difference between the highest and the lowest Cost of computers, communications and other services (% of commerical service exports) in Jordan?
Offer a terse response. 4.75. 